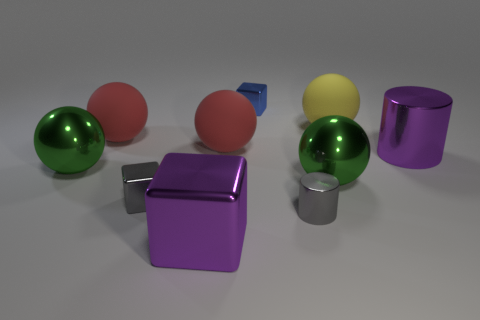What is the color of the large metal block?
Give a very brief answer. Purple. The metallic object that is the same color as the big cylinder is what shape?
Keep it short and to the point. Cube. Is there a yellow cube?
Your answer should be very brief. No. There is a blue object that is the same material as the large cylinder; what size is it?
Your answer should be compact. Small. What shape is the small metal object behind the big red object that is behind the big red sphere right of the large purple shiny block?
Your response must be concise. Cube. Is the number of green things left of the small blue thing the same as the number of cyan blocks?
Provide a short and direct response. No. The cube that is the same color as the small shiny cylinder is what size?
Provide a succinct answer. Small. Do the blue object and the yellow object have the same shape?
Keep it short and to the point. No. How many objects are either large purple objects that are in front of the large purple metal cylinder or green balls?
Offer a very short reply. 3. Are there an equal number of tiny blue metal cubes that are behind the big yellow rubber ball and red matte spheres that are in front of the purple block?
Ensure brevity in your answer.  No. 